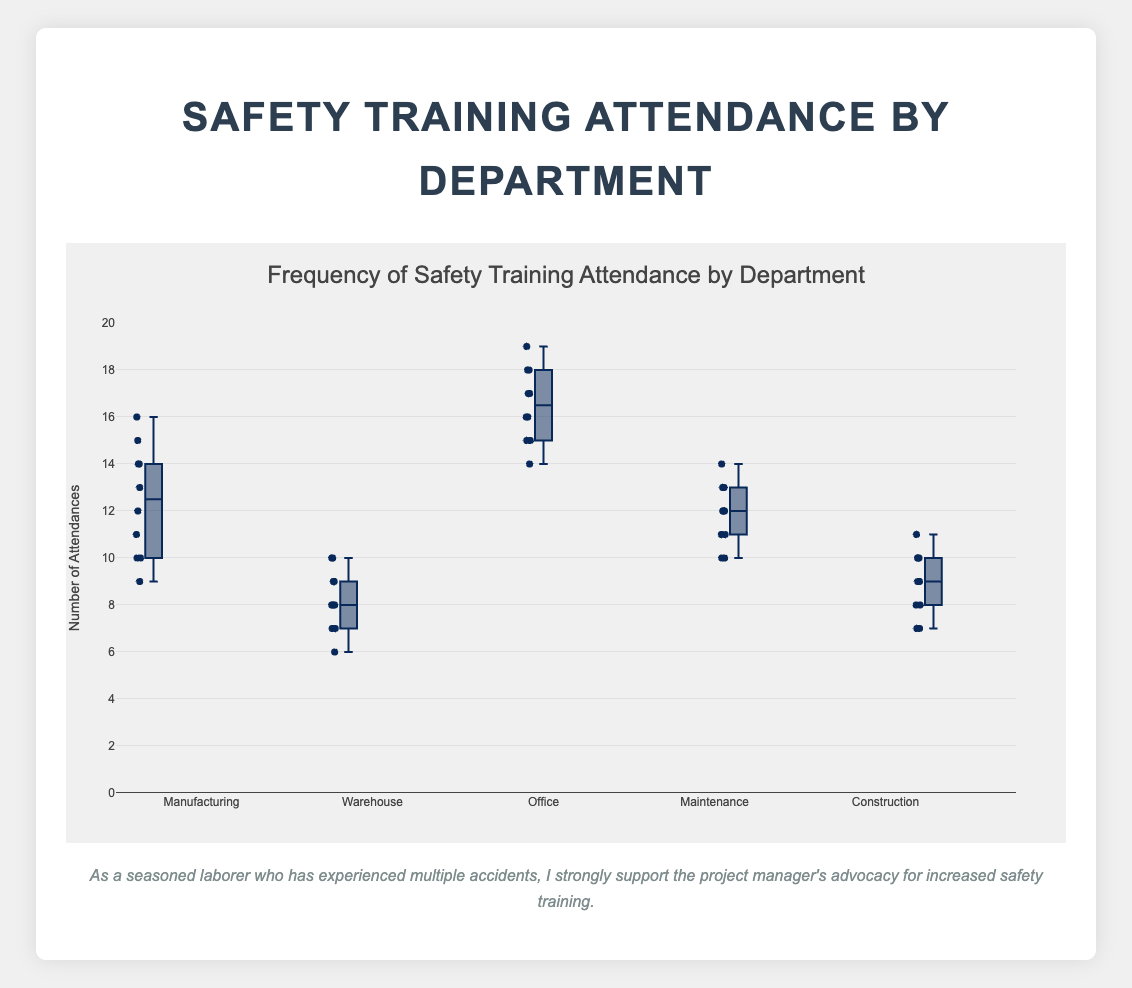How many attendances are recorded for the Office department? Count the data points shown in the plot for the Office department, which should be the number of data points listed in the data.
Answer: 10 What is the title of the plot? Look at the top of the plot where the title is displayed.
Answer: Frequency of Safety Training Attendance by Department Which department has the highest median attendance? Check the median line (usually the line inside the box) for each department and identify the highest one.
Answer: Office Is the range of attendance in the Manufacturing department wider than in the Warehouse department? Compare the vertical span (range) of the boxplots of Manufacturing and Warehouse.
Answer: Yes What are the interquartile ranges (IQR) for the Maintenance department? The IQR is the range between the 25th percentile (bottom of the box) and the 75th percentile (top of the box). Identify these values on the Maintenance box plot.
Answer: 2 Which department shows the most consistent attendance? Check which department has the smallest range (distance between the minimum and maximum values).
Answer: Warehouse What is the minimum attendance recorded in the Construction department? Identify the lowest point on the Construction box plot.
Answer: 7 Which department has the most outliers in attendance? Look for departments with data points outside the whiskers of their box plot. Count and compare them.
Answer: None (no outliers visible) How does the median attendance for the Manufacturing department compare to that of the Construction department? Compare the median lines (inside the boxes) of both departments' box plots.
Answer: Higher Between the Manufacturing and Office departments, which one has a greater spread of attendance values? Compare the total range from the minimum to the maximum values in each box plot.
Answer: Manufacturing 